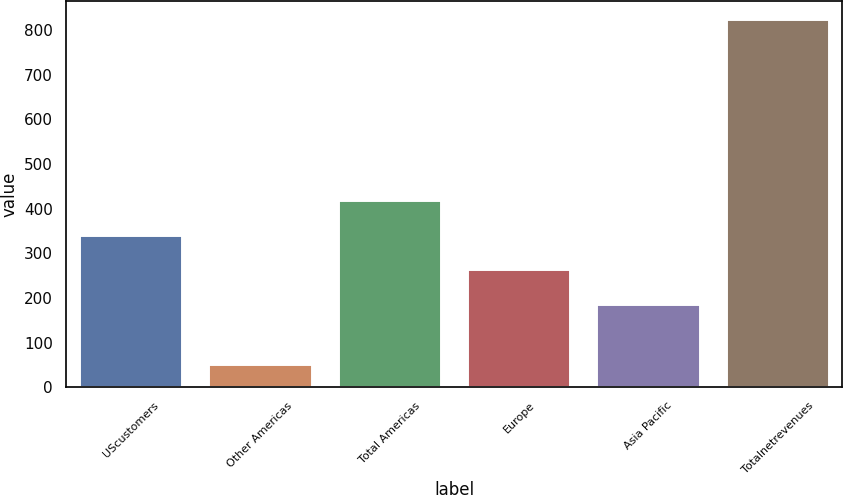<chart> <loc_0><loc_0><loc_500><loc_500><bar_chart><fcel>UScustomers<fcel>Other Americas<fcel>Total Americas<fcel>Europe<fcel>Asia Pacific<fcel>Totalnetrevenues<nl><fcel>341.78<fcel>52.5<fcel>419.02<fcel>264.54<fcel>187.3<fcel>824.9<nl></chart> 